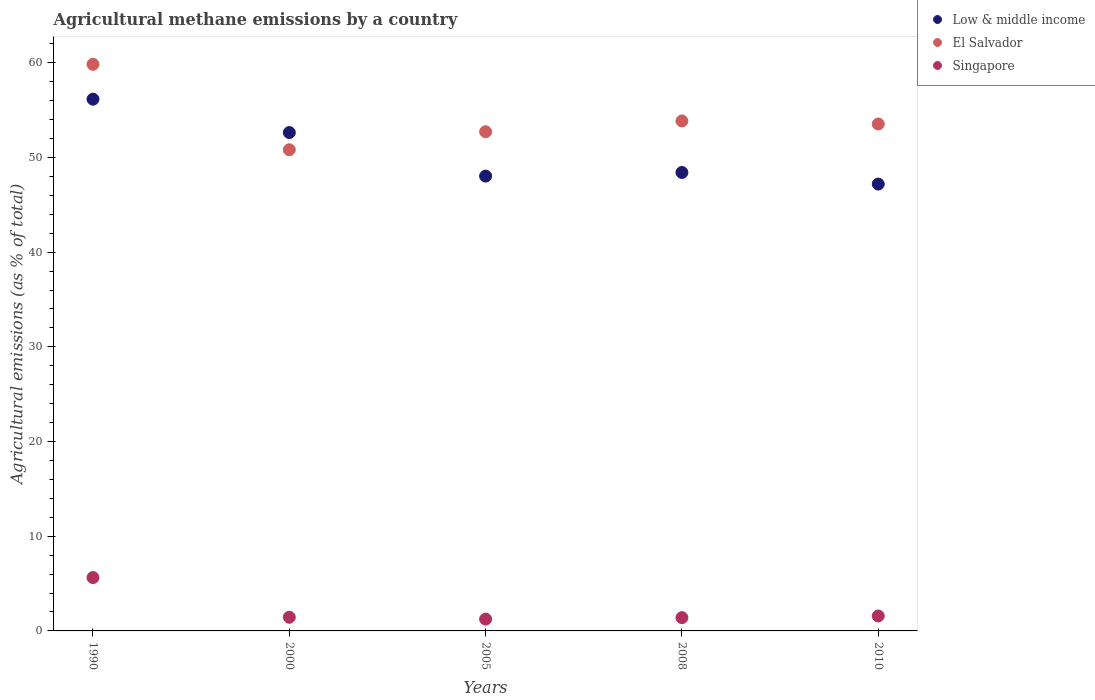How many different coloured dotlines are there?
Your response must be concise. 3. What is the amount of agricultural methane emitted in Low & middle income in 2005?
Give a very brief answer. 48.04. Across all years, what is the maximum amount of agricultural methane emitted in Singapore?
Make the answer very short. 5.63. Across all years, what is the minimum amount of agricultural methane emitted in Singapore?
Make the answer very short. 1.25. In which year was the amount of agricultural methane emitted in Singapore maximum?
Keep it short and to the point. 1990. What is the total amount of agricultural methane emitted in Low & middle income in the graph?
Give a very brief answer. 252.44. What is the difference between the amount of agricultural methane emitted in Low & middle income in 1990 and that in 2008?
Ensure brevity in your answer.  7.74. What is the difference between the amount of agricultural methane emitted in Singapore in 2005 and the amount of agricultural methane emitted in El Salvador in 2008?
Ensure brevity in your answer.  -52.61. What is the average amount of agricultural methane emitted in El Salvador per year?
Keep it short and to the point. 54.16. In the year 2005, what is the difference between the amount of agricultural methane emitted in El Salvador and amount of agricultural methane emitted in Singapore?
Ensure brevity in your answer.  51.47. In how many years, is the amount of agricultural methane emitted in Low & middle income greater than 36 %?
Ensure brevity in your answer.  5. What is the ratio of the amount of agricultural methane emitted in Low & middle income in 2008 to that in 2010?
Your answer should be compact. 1.03. What is the difference between the highest and the second highest amount of agricultural methane emitted in Low & middle income?
Offer a very short reply. 3.52. What is the difference between the highest and the lowest amount of agricultural methane emitted in El Salvador?
Give a very brief answer. 9.02. In how many years, is the amount of agricultural methane emitted in Singapore greater than the average amount of agricultural methane emitted in Singapore taken over all years?
Your answer should be very brief. 1. Is the sum of the amount of agricultural methane emitted in El Salvador in 2005 and 2010 greater than the maximum amount of agricultural methane emitted in Singapore across all years?
Provide a succinct answer. Yes. Is it the case that in every year, the sum of the amount of agricultural methane emitted in El Salvador and amount of agricultural methane emitted in Singapore  is greater than the amount of agricultural methane emitted in Low & middle income?
Your answer should be very brief. No. Does the amount of agricultural methane emitted in El Salvador monotonically increase over the years?
Your answer should be very brief. No. Is the amount of agricultural methane emitted in Low & middle income strictly less than the amount of agricultural methane emitted in El Salvador over the years?
Provide a short and direct response. No. How many dotlines are there?
Ensure brevity in your answer.  3. What is the difference between two consecutive major ticks on the Y-axis?
Your answer should be compact. 10. Are the values on the major ticks of Y-axis written in scientific E-notation?
Your answer should be compact. No. Does the graph contain any zero values?
Your answer should be compact. No. Where does the legend appear in the graph?
Give a very brief answer. Top right. How are the legend labels stacked?
Offer a terse response. Vertical. What is the title of the graph?
Keep it short and to the point. Agricultural methane emissions by a country. Does "Trinidad and Tobago" appear as one of the legend labels in the graph?
Your answer should be compact. No. What is the label or title of the Y-axis?
Make the answer very short. Agricultural emissions (as % of total). What is the Agricultural emissions (as % of total) of Low & middle income in 1990?
Your response must be concise. 56.16. What is the Agricultural emissions (as % of total) in El Salvador in 1990?
Give a very brief answer. 59.84. What is the Agricultural emissions (as % of total) of Singapore in 1990?
Your response must be concise. 5.63. What is the Agricultural emissions (as % of total) in Low & middle income in 2000?
Offer a very short reply. 52.63. What is the Agricultural emissions (as % of total) in El Salvador in 2000?
Keep it short and to the point. 50.82. What is the Agricultural emissions (as % of total) of Singapore in 2000?
Give a very brief answer. 1.44. What is the Agricultural emissions (as % of total) in Low & middle income in 2005?
Your answer should be very brief. 48.04. What is the Agricultural emissions (as % of total) in El Salvador in 2005?
Give a very brief answer. 52.72. What is the Agricultural emissions (as % of total) of Singapore in 2005?
Give a very brief answer. 1.25. What is the Agricultural emissions (as % of total) in Low & middle income in 2008?
Your answer should be very brief. 48.42. What is the Agricultural emissions (as % of total) in El Salvador in 2008?
Keep it short and to the point. 53.86. What is the Agricultural emissions (as % of total) of Singapore in 2008?
Ensure brevity in your answer.  1.4. What is the Agricultural emissions (as % of total) in Low & middle income in 2010?
Your response must be concise. 47.19. What is the Agricultural emissions (as % of total) in El Salvador in 2010?
Your answer should be compact. 53.54. What is the Agricultural emissions (as % of total) of Singapore in 2010?
Keep it short and to the point. 1.58. Across all years, what is the maximum Agricultural emissions (as % of total) of Low & middle income?
Make the answer very short. 56.16. Across all years, what is the maximum Agricultural emissions (as % of total) of El Salvador?
Your answer should be compact. 59.84. Across all years, what is the maximum Agricultural emissions (as % of total) of Singapore?
Offer a very short reply. 5.63. Across all years, what is the minimum Agricultural emissions (as % of total) in Low & middle income?
Keep it short and to the point. 47.19. Across all years, what is the minimum Agricultural emissions (as % of total) in El Salvador?
Provide a short and direct response. 50.82. Across all years, what is the minimum Agricultural emissions (as % of total) in Singapore?
Give a very brief answer. 1.25. What is the total Agricultural emissions (as % of total) in Low & middle income in the graph?
Make the answer very short. 252.44. What is the total Agricultural emissions (as % of total) in El Salvador in the graph?
Provide a short and direct response. 270.78. What is the total Agricultural emissions (as % of total) in Singapore in the graph?
Offer a terse response. 11.3. What is the difference between the Agricultural emissions (as % of total) in Low & middle income in 1990 and that in 2000?
Your response must be concise. 3.52. What is the difference between the Agricultural emissions (as % of total) in El Salvador in 1990 and that in 2000?
Provide a short and direct response. 9.02. What is the difference between the Agricultural emissions (as % of total) in Singapore in 1990 and that in 2000?
Offer a terse response. 4.19. What is the difference between the Agricultural emissions (as % of total) of Low & middle income in 1990 and that in 2005?
Offer a very short reply. 8.12. What is the difference between the Agricultural emissions (as % of total) of El Salvador in 1990 and that in 2005?
Offer a very short reply. 7.12. What is the difference between the Agricultural emissions (as % of total) in Singapore in 1990 and that in 2005?
Ensure brevity in your answer.  4.39. What is the difference between the Agricultural emissions (as % of total) of Low & middle income in 1990 and that in 2008?
Keep it short and to the point. 7.74. What is the difference between the Agricultural emissions (as % of total) of El Salvador in 1990 and that in 2008?
Your response must be concise. 5.98. What is the difference between the Agricultural emissions (as % of total) of Singapore in 1990 and that in 2008?
Provide a short and direct response. 4.23. What is the difference between the Agricultural emissions (as % of total) in Low & middle income in 1990 and that in 2010?
Your answer should be compact. 8.97. What is the difference between the Agricultural emissions (as % of total) of El Salvador in 1990 and that in 2010?
Your answer should be very brief. 6.3. What is the difference between the Agricultural emissions (as % of total) of Singapore in 1990 and that in 2010?
Ensure brevity in your answer.  4.06. What is the difference between the Agricultural emissions (as % of total) of Low & middle income in 2000 and that in 2005?
Provide a short and direct response. 4.6. What is the difference between the Agricultural emissions (as % of total) of El Salvador in 2000 and that in 2005?
Keep it short and to the point. -1.9. What is the difference between the Agricultural emissions (as % of total) of Singapore in 2000 and that in 2005?
Offer a terse response. 0.2. What is the difference between the Agricultural emissions (as % of total) of Low & middle income in 2000 and that in 2008?
Your response must be concise. 4.22. What is the difference between the Agricultural emissions (as % of total) in El Salvador in 2000 and that in 2008?
Provide a short and direct response. -3.04. What is the difference between the Agricultural emissions (as % of total) in Singapore in 2000 and that in 2008?
Offer a terse response. 0.04. What is the difference between the Agricultural emissions (as % of total) of Low & middle income in 2000 and that in 2010?
Ensure brevity in your answer.  5.44. What is the difference between the Agricultural emissions (as % of total) in El Salvador in 2000 and that in 2010?
Give a very brief answer. -2.72. What is the difference between the Agricultural emissions (as % of total) of Singapore in 2000 and that in 2010?
Offer a terse response. -0.13. What is the difference between the Agricultural emissions (as % of total) in Low & middle income in 2005 and that in 2008?
Keep it short and to the point. -0.38. What is the difference between the Agricultural emissions (as % of total) of El Salvador in 2005 and that in 2008?
Provide a short and direct response. -1.14. What is the difference between the Agricultural emissions (as % of total) in Singapore in 2005 and that in 2008?
Ensure brevity in your answer.  -0.15. What is the difference between the Agricultural emissions (as % of total) of Low & middle income in 2005 and that in 2010?
Keep it short and to the point. 0.84. What is the difference between the Agricultural emissions (as % of total) in El Salvador in 2005 and that in 2010?
Make the answer very short. -0.82. What is the difference between the Agricultural emissions (as % of total) in Singapore in 2005 and that in 2010?
Your answer should be compact. -0.33. What is the difference between the Agricultural emissions (as % of total) of Low & middle income in 2008 and that in 2010?
Your response must be concise. 1.23. What is the difference between the Agricultural emissions (as % of total) in El Salvador in 2008 and that in 2010?
Keep it short and to the point. 0.32. What is the difference between the Agricultural emissions (as % of total) in Singapore in 2008 and that in 2010?
Make the answer very short. -0.18. What is the difference between the Agricultural emissions (as % of total) of Low & middle income in 1990 and the Agricultural emissions (as % of total) of El Salvador in 2000?
Your response must be concise. 5.34. What is the difference between the Agricultural emissions (as % of total) in Low & middle income in 1990 and the Agricultural emissions (as % of total) in Singapore in 2000?
Keep it short and to the point. 54.72. What is the difference between the Agricultural emissions (as % of total) in El Salvador in 1990 and the Agricultural emissions (as % of total) in Singapore in 2000?
Ensure brevity in your answer.  58.4. What is the difference between the Agricultural emissions (as % of total) of Low & middle income in 1990 and the Agricultural emissions (as % of total) of El Salvador in 2005?
Ensure brevity in your answer.  3.44. What is the difference between the Agricultural emissions (as % of total) in Low & middle income in 1990 and the Agricultural emissions (as % of total) in Singapore in 2005?
Your answer should be compact. 54.91. What is the difference between the Agricultural emissions (as % of total) in El Salvador in 1990 and the Agricultural emissions (as % of total) in Singapore in 2005?
Give a very brief answer. 58.59. What is the difference between the Agricultural emissions (as % of total) in Low & middle income in 1990 and the Agricultural emissions (as % of total) in El Salvador in 2008?
Keep it short and to the point. 2.3. What is the difference between the Agricultural emissions (as % of total) in Low & middle income in 1990 and the Agricultural emissions (as % of total) in Singapore in 2008?
Your response must be concise. 54.76. What is the difference between the Agricultural emissions (as % of total) in El Salvador in 1990 and the Agricultural emissions (as % of total) in Singapore in 2008?
Keep it short and to the point. 58.44. What is the difference between the Agricultural emissions (as % of total) of Low & middle income in 1990 and the Agricultural emissions (as % of total) of El Salvador in 2010?
Keep it short and to the point. 2.62. What is the difference between the Agricultural emissions (as % of total) of Low & middle income in 1990 and the Agricultural emissions (as % of total) of Singapore in 2010?
Your answer should be very brief. 54.58. What is the difference between the Agricultural emissions (as % of total) of El Salvador in 1990 and the Agricultural emissions (as % of total) of Singapore in 2010?
Your answer should be very brief. 58.26. What is the difference between the Agricultural emissions (as % of total) of Low & middle income in 2000 and the Agricultural emissions (as % of total) of El Salvador in 2005?
Offer a terse response. -0.08. What is the difference between the Agricultural emissions (as % of total) of Low & middle income in 2000 and the Agricultural emissions (as % of total) of Singapore in 2005?
Ensure brevity in your answer.  51.39. What is the difference between the Agricultural emissions (as % of total) of El Salvador in 2000 and the Agricultural emissions (as % of total) of Singapore in 2005?
Keep it short and to the point. 49.57. What is the difference between the Agricultural emissions (as % of total) in Low & middle income in 2000 and the Agricultural emissions (as % of total) in El Salvador in 2008?
Make the answer very short. -1.23. What is the difference between the Agricultural emissions (as % of total) in Low & middle income in 2000 and the Agricultural emissions (as % of total) in Singapore in 2008?
Keep it short and to the point. 51.23. What is the difference between the Agricultural emissions (as % of total) in El Salvador in 2000 and the Agricultural emissions (as % of total) in Singapore in 2008?
Ensure brevity in your answer.  49.41. What is the difference between the Agricultural emissions (as % of total) of Low & middle income in 2000 and the Agricultural emissions (as % of total) of El Salvador in 2010?
Offer a very short reply. -0.9. What is the difference between the Agricultural emissions (as % of total) in Low & middle income in 2000 and the Agricultural emissions (as % of total) in Singapore in 2010?
Provide a succinct answer. 51.06. What is the difference between the Agricultural emissions (as % of total) of El Salvador in 2000 and the Agricultural emissions (as % of total) of Singapore in 2010?
Your answer should be compact. 49.24. What is the difference between the Agricultural emissions (as % of total) of Low & middle income in 2005 and the Agricultural emissions (as % of total) of El Salvador in 2008?
Your answer should be compact. -5.82. What is the difference between the Agricultural emissions (as % of total) of Low & middle income in 2005 and the Agricultural emissions (as % of total) of Singapore in 2008?
Ensure brevity in your answer.  46.63. What is the difference between the Agricultural emissions (as % of total) in El Salvador in 2005 and the Agricultural emissions (as % of total) in Singapore in 2008?
Ensure brevity in your answer.  51.32. What is the difference between the Agricultural emissions (as % of total) in Low & middle income in 2005 and the Agricultural emissions (as % of total) in El Salvador in 2010?
Provide a succinct answer. -5.5. What is the difference between the Agricultural emissions (as % of total) of Low & middle income in 2005 and the Agricultural emissions (as % of total) of Singapore in 2010?
Offer a terse response. 46.46. What is the difference between the Agricultural emissions (as % of total) of El Salvador in 2005 and the Agricultural emissions (as % of total) of Singapore in 2010?
Offer a terse response. 51.14. What is the difference between the Agricultural emissions (as % of total) in Low & middle income in 2008 and the Agricultural emissions (as % of total) in El Salvador in 2010?
Offer a terse response. -5.12. What is the difference between the Agricultural emissions (as % of total) in Low & middle income in 2008 and the Agricultural emissions (as % of total) in Singapore in 2010?
Your answer should be compact. 46.84. What is the difference between the Agricultural emissions (as % of total) in El Salvador in 2008 and the Agricultural emissions (as % of total) in Singapore in 2010?
Offer a terse response. 52.28. What is the average Agricultural emissions (as % of total) in Low & middle income per year?
Ensure brevity in your answer.  50.49. What is the average Agricultural emissions (as % of total) of El Salvador per year?
Provide a short and direct response. 54.16. What is the average Agricultural emissions (as % of total) in Singapore per year?
Your answer should be very brief. 2.26. In the year 1990, what is the difference between the Agricultural emissions (as % of total) in Low & middle income and Agricultural emissions (as % of total) in El Salvador?
Your answer should be compact. -3.68. In the year 1990, what is the difference between the Agricultural emissions (as % of total) of Low & middle income and Agricultural emissions (as % of total) of Singapore?
Keep it short and to the point. 50.52. In the year 1990, what is the difference between the Agricultural emissions (as % of total) in El Salvador and Agricultural emissions (as % of total) in Singapore?
Your answer should be very brief. 54.21. In the year 2000, what is the difference between the Agricultural emissions (as % of total) of Low & middle income and Agricultural emissions (as % of total) of El Salvador?
Your answer should be very brief. 1.82. In the year 2000, what is the difference between the Agricultural emissions (as % of total) in Low & middle income and Agricultural emissions (as % of total) in Singapore?
Give a very brief answer. 51.19. In the year 2000, what is the difference between the Agricultural emissions (as % of total) of El Salvador and Agricultural emissions (as % of total) of Singapore?
Ensure brevity in your answer.  49.37. In the year 2005, what is the difference between the Agricultural emissions (as % of total) of Low & middle income and Agricultural emissions (as % of total) of El Salvador?
Ensure brevity in your answer.  -4.68. In the year 2005, what is the difference between the Agricultural emissions (as % of total) of Low & middle income and Agricultural emissions (as % of total) of Singapore?
Your answer should be very brief. 46.79. In the year 2005, what is the difference between the Agricultural emissions (as % of total) of El Salvador and Agricultural emissions (as % of total) of Singapore?
Your answer should be very brief. 51.47. In the year 2008, what is the difference between the Agricultural emissions (as % of total) of Low & middle income and Agricultural emissions (as % of total) of El Salvador?
Offer a very short reply. -5.44. In the year 2008, what is the difference between the Agricultural emissions (as % of total) in Low & middle income and Agricultural emissions (as % of total) in Singapore?
Keep it short and to the point. 47.02. In the year 2008, what is the difference between the Agricultural emissions (as % of total) in El Salvador and Agricultural emissions (as % of total) in Singapore?
Your response must be concise. 52.46. In the year 2010, what is the difference between the Agricultural emissions (as % of total) in Low & middle income and Agricultural emissions (as % of total) in El Salvador?
Give a very brief answer. -6.35. In the year 2010, what is the difference between the Agricultural emissions (as % of total) in Low & middle income and Agricultural emissions (as % of total) in Singapore?
Keep it short and to the point. 45.61. In the year 2010, what is the difference between the Agricultural emissions (as % of total) in El Salvador and Agricultural emissions (as % of total) in Singapore?
Give a very brief answer. 51.96. What is the ratio of the Agricultural emissions (as % of total) of Low & middle income in 1990 to that in 2000?
Make the answer very short. 1.07. What is the ratio of the Agricultural emissions (as % of total) in El Salvador in 1990 to that in 2000?
Your answer should be very brief. 1.18. What is the ratio of the Agricultural emissions (as % of total) in Singapore in 1990 to that in 2000?
Offer a terse response. 3.9. What is the ratio of the Agricultural emissions (as % of total) of Low & middle income in 1990 to that in 2005?
Ensure brevity in your answer.  1.17. What is the ratio of the Agricultural emissions (as % of total) in El Salvador in 1990 to that in 2005?
Give a very brief answer. 1.14. What is the ratio of the Agricultural emissions (as % of total) of Singapore in 1990 to that in 2005?
Make the answer very short. 4.52. What is the ratio of the Agricultural emissions (as % of total) of Low & middle income in 1990 to that in 2008?
Provide a succinct answer. 1.16. What is the ratio of the Agricultural emissions (as % of total) of El Salvador in 1990 to that in 2008?
Provide a succinct answer. 1.11. What is the ratio of the Agricultural emissions (as % of total) of Singapore in 1990 to that in 2008?
Give a very brief answer. 4.02. What is the ratio of the Agricultural emissions (as % of total) in Low & middle income in 1990 to that in 2010?
Your answer should be very brief. 1.19. What is the ratio of the Agricultural emissions (as % of total) in El Salvador in 1990 to that in 2010?
Give a very brief answer. 1.12. What is the ratio of the Agricultural emissions (as % of total) in Singapore in 1990 to that in 2010?
Provide a short and direct response. 3.57. What is the ratio of the Agricultural emissions (as % of total) in Low & middle income in 2000 to that in 2005?
Provide a short and direct response. 1.1. What is the ratio of the Agricultural emissions (as % of total) in El Salvador in 2000 to that in 2005?
Keep it short and to the point. 0.96. What is the ratio of the Agricultural emissions (as % of total) of Singapore in 2000 to that in 2005?
Offer a very short reply. 1.16. What is the ratio of the Agricultural emissions (as % of total) of Low & middle income in 2000 to that in 2008?
Provide a succinct answer. 1.09. What is the ratio of the Agricultural emissions (as % of total) in El Salvador in 2000 to that in 2008?
Give a very brief answer. 0.94. What is the ratio of the Agricultural emissions (as % of total) of Singapore in 2000 to that in 2008?
Your response must be concise. 1.03. What is the ratio of the Agricultural emissions (as % of total) in Low & middle income in 2000 to that in 2010?
Your response must be concise. 1.12. What is the ratio of the Agricultural emissions (as % of total) in El Salvador in 2000 to that in 2010?
Keep it short and to the point. 0.95. What is the ratio of the Agricultural emissions (as % of total) of Singapore in 2000 to that in 2010?
Offer a very short reply. 0.91. What is the ratio of the Agricultural emissions (as % of total) in Low & middle income in 2005 to that in 2008?
Your answer should be compact. 0.99. What is the ratio of the Agricultural emissions (as % of total) of El Salvador in 2005 to that in 2008?
Provide a succinct answer. 0.98. What is the ratio of the Agricultural emissions (as % of total) of Singapore in 2005 to that in 2008?
Your answer should be compact. 0.89. What is the ratio of the Agricultural emissions (as % of total) in Low & middle income in 2005 to that in 2010?
Provide a succinct answer. 1.02. What is the ratio of the Agricultural emissions (as % of total) of El Salvador in 2005 to that in 2010?
Make the answer very short. 0.98. What is the ratio of the Agricultural emissions (as % of total) of Singapore in 2005 to that in 2010?
Provide a succinct answer. 0.79. What is the ratio of the Agricultural emissions (as % of total) in Low & middle income in 2008 to that in 2010?
Keep it short and to the point. 1.03. What is the ratio of the Agricultural emissions (as % of total) of El Salvador in 2008 to that in 2010?
Offer a terse response. 1.01. What is the ratio of the Agricultural emissions (as % of total) in Singapore in 2008 to that in 2010?
Your answer should be compact. 0.89. What is the difference between the highest and the second highest Agricultural emissions (as % of total) of Low & middle income?
Ensure brevity in your answer.  3.52. What is the difference between the highest and the second highest Agricultural emissions (as % of total) in El Salvador?
Offer a very short reply. 5.98. What is the difference between the highest and the second highest Agricultural emissions (as % of total) in Singapore?
Keep it short and to the point. 4.06. What is the difference between the highest and the lowest Agricultural emissions (as % of total) in Low & middle income?
Keep it short and to the point. 8.97. What is the difference between the highest and the lowest Agricultural emissions (as % of total) in El Salvador?
Ensure brevity in your answer.  9.02. What is the difference between the highest and the lowest Agricultural emissions (as % of total) in Singapore?
Offer a terse response. 4.39. 